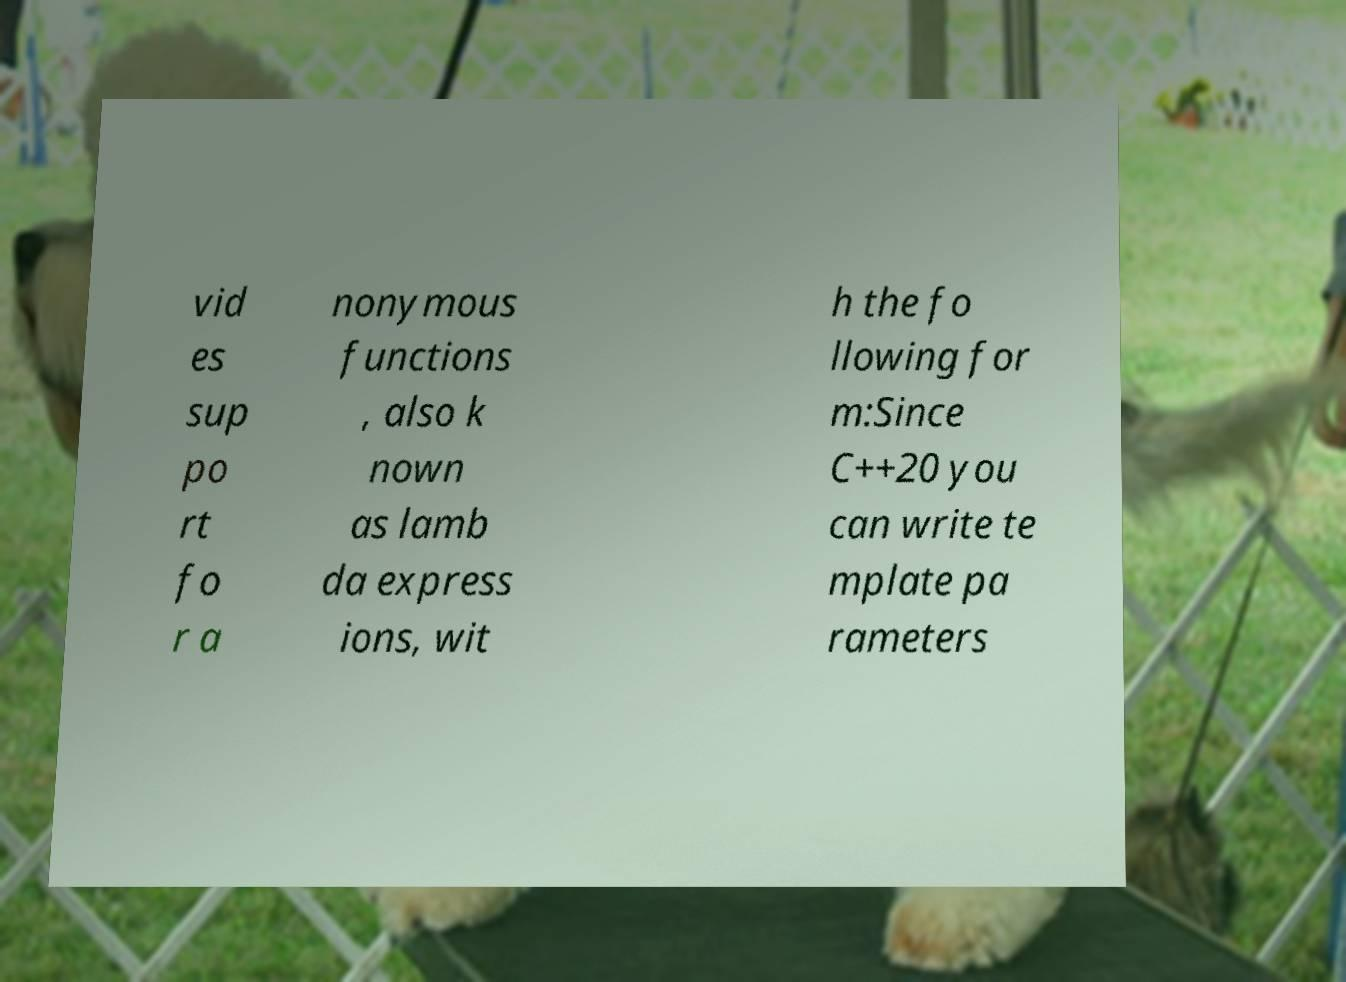Could you extract and type out the text from this image? vid es sup po rt fo r a nonymous functions , also k nown as lamb da express ions, wit h the fo llowing for m:Since C++20 you can write te mplate pa rameters 